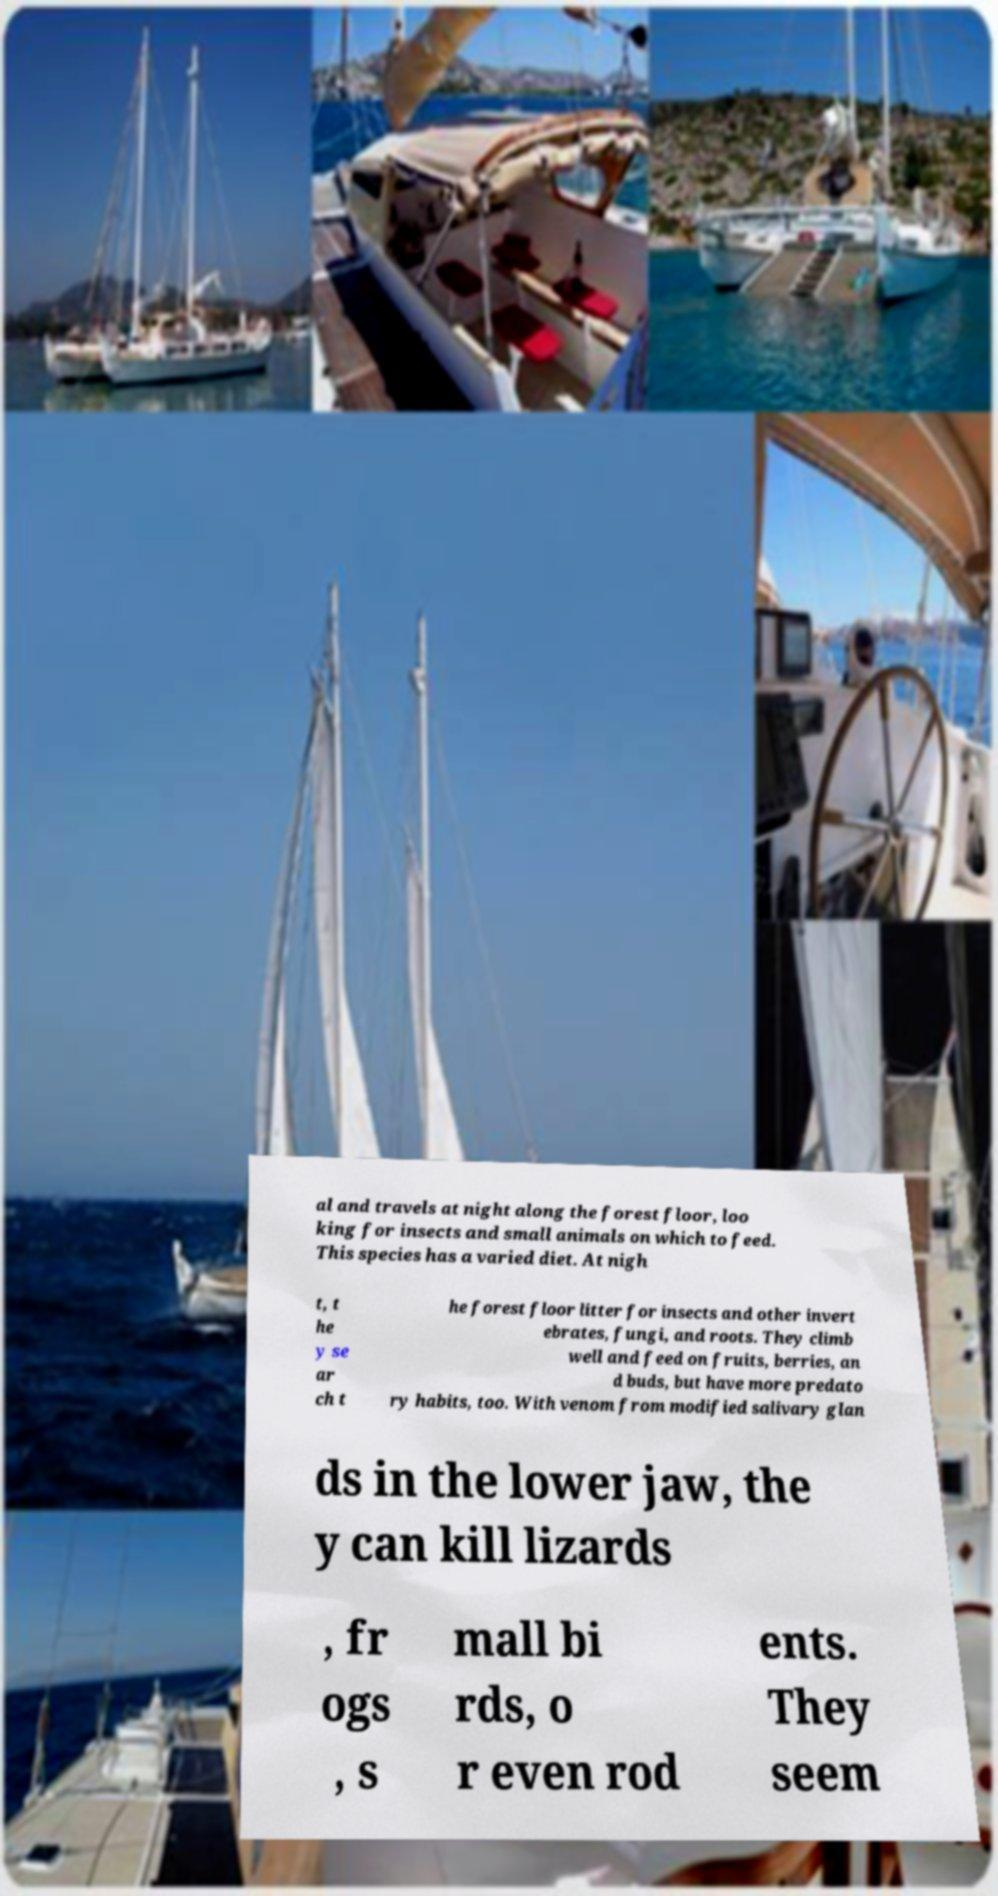Could you assist in decoding the text presented in this image and type it out clearly? al and travels at night along the forest floor, loo king for insects and small animals on which to feed. This species has a varied diet. At nigh t, t he y se ar ch t he forest floor litter for insects and other invert ebrates, fungi, and roots. They climb well and feed on fruits, berries, an d buds, but have more predato ry habits, too. With venom from modified salivary glan ds in the lower jaw, the y can kill lizards , fr ogs , s mall bi rds, o r even rod ents. They seem 